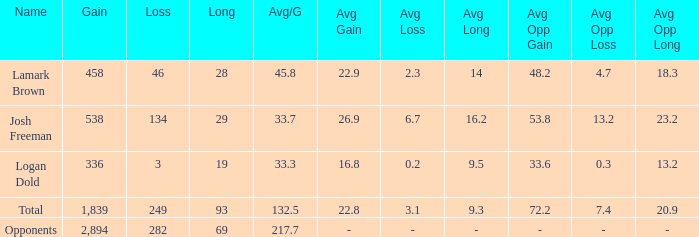Which avg/g is associated with josh freeman and has a loss under 134? None. 